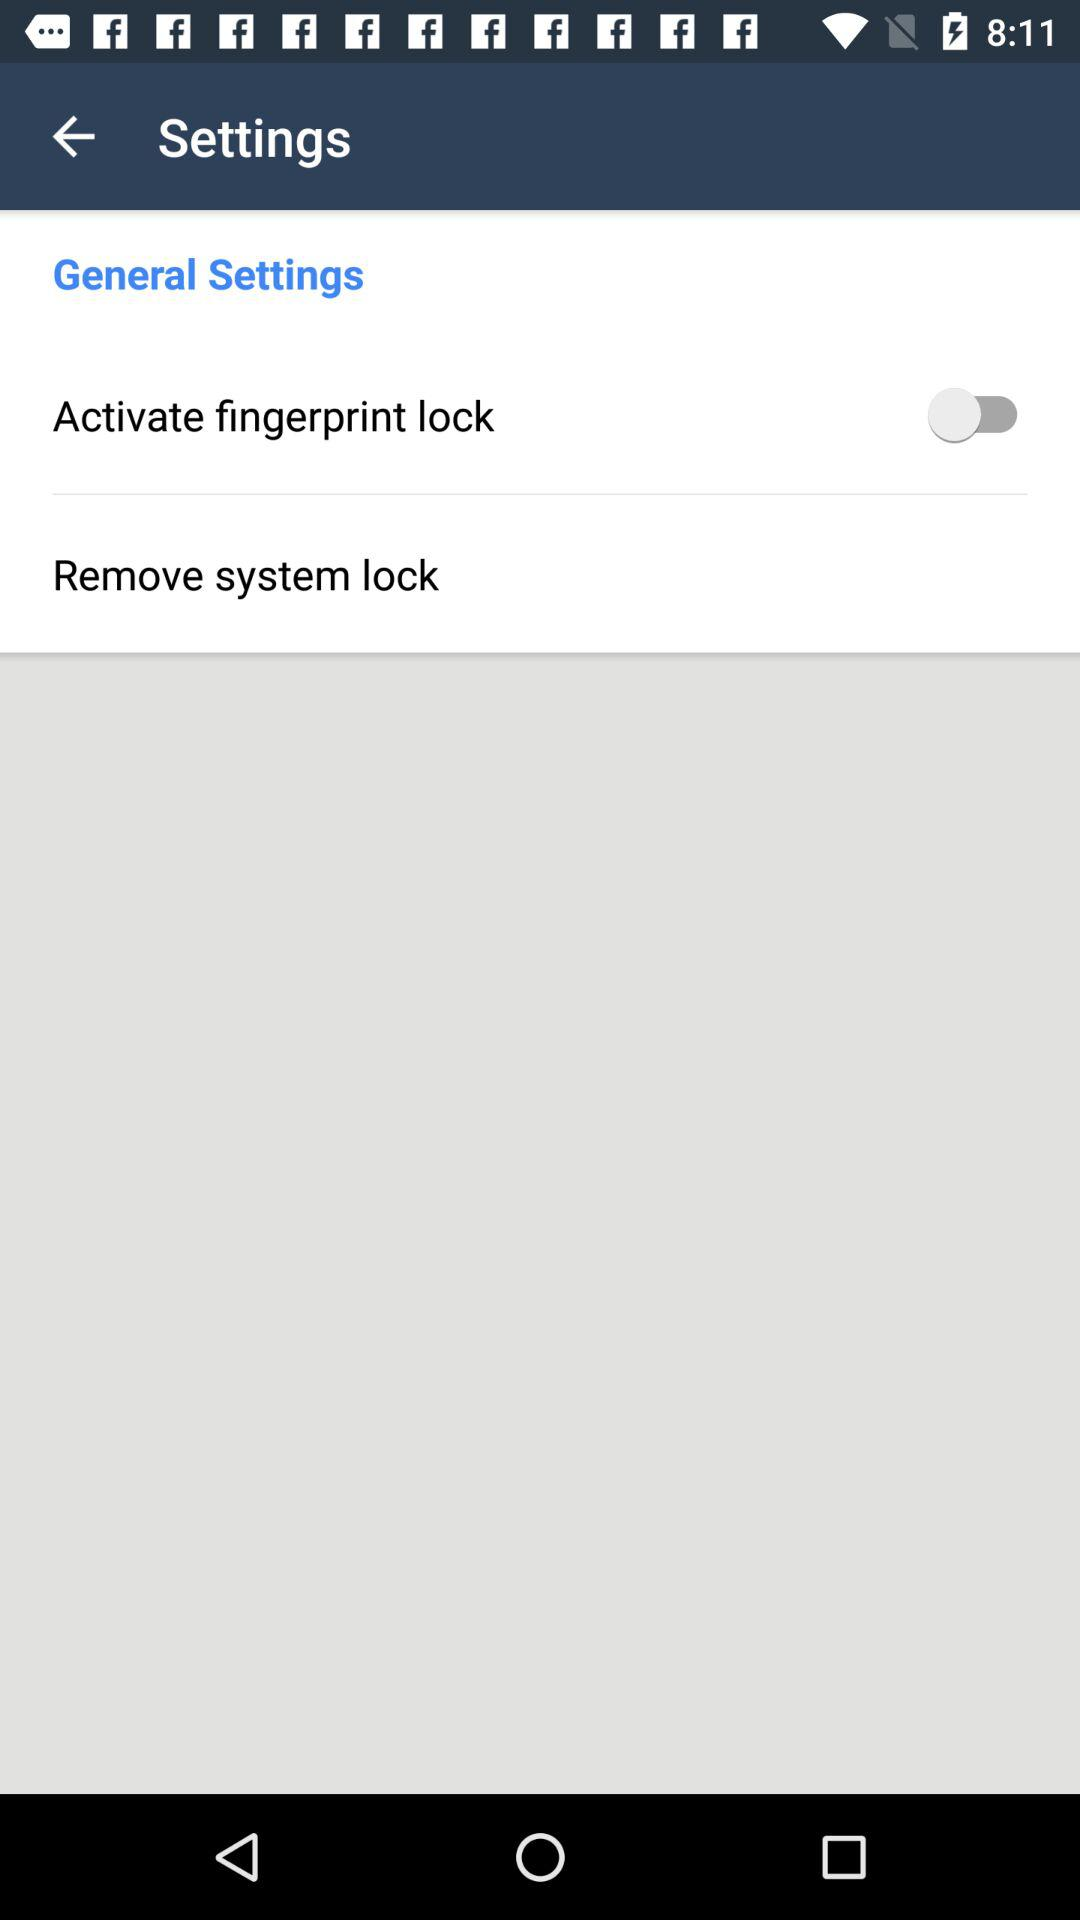What is the status of "Activate fingerprint lock"? The status of "Activate fingerprint lock" is "off". 